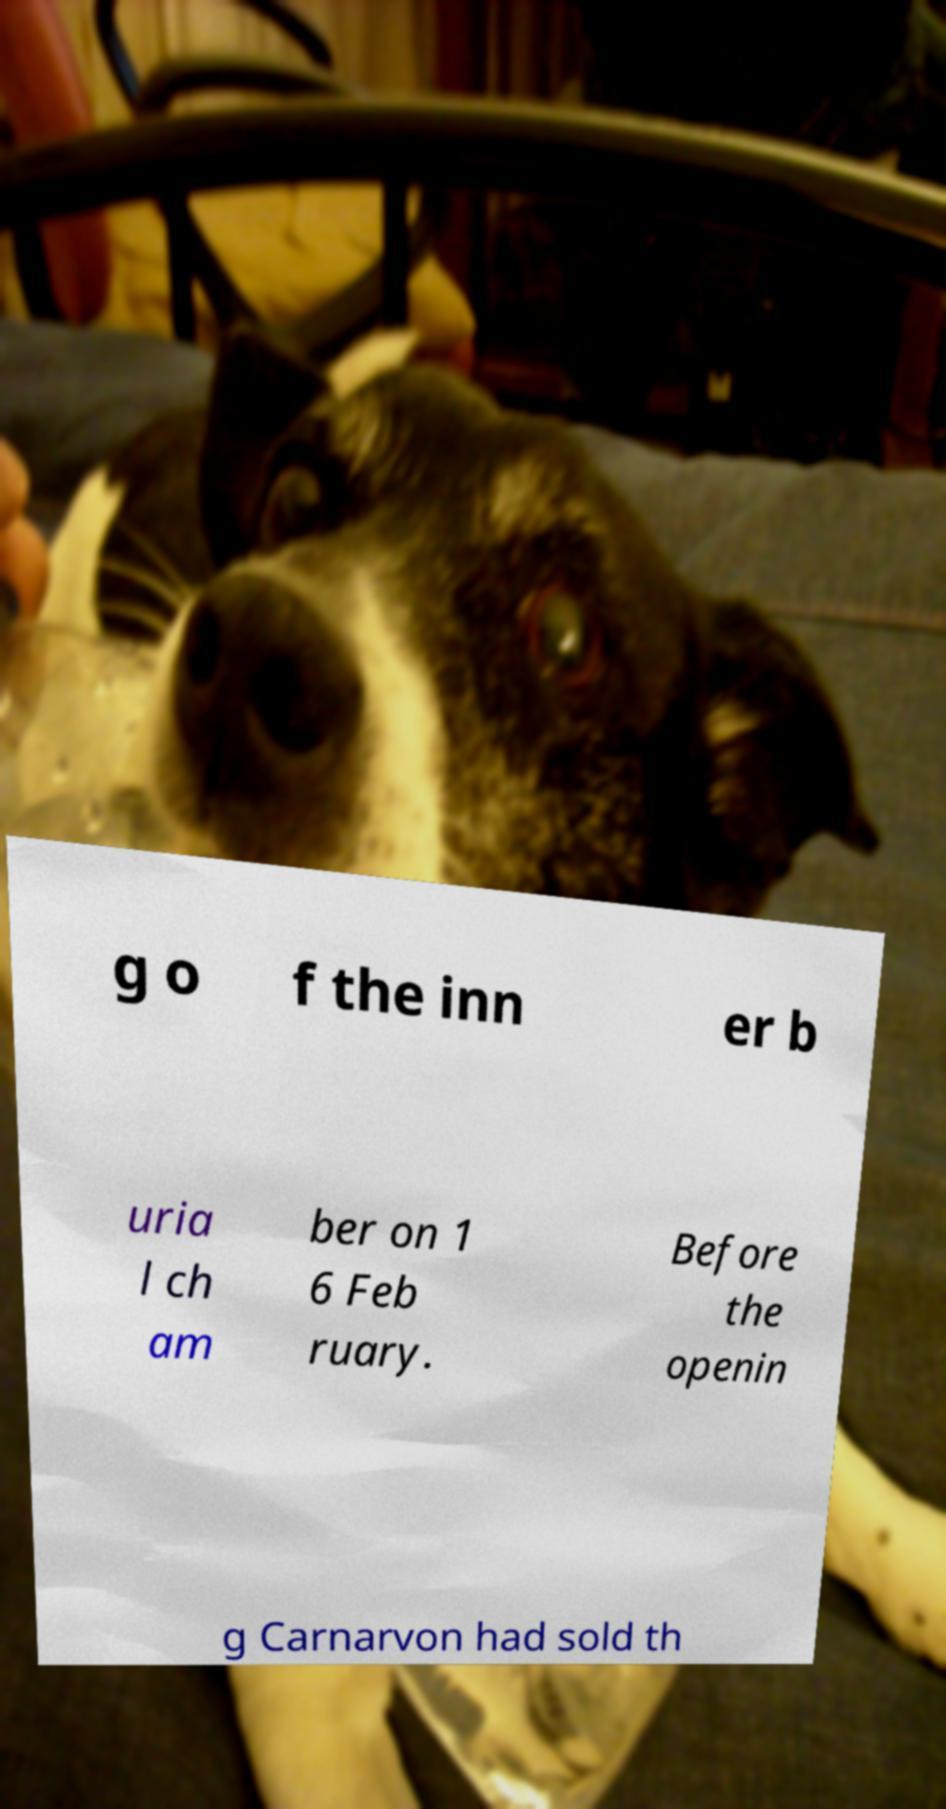Please identify and transcribe the text found in this image. g o f the inn er b uria l ch am ber on 1 6 Feb ruary. Before the openin g Carnarvon had sold th 